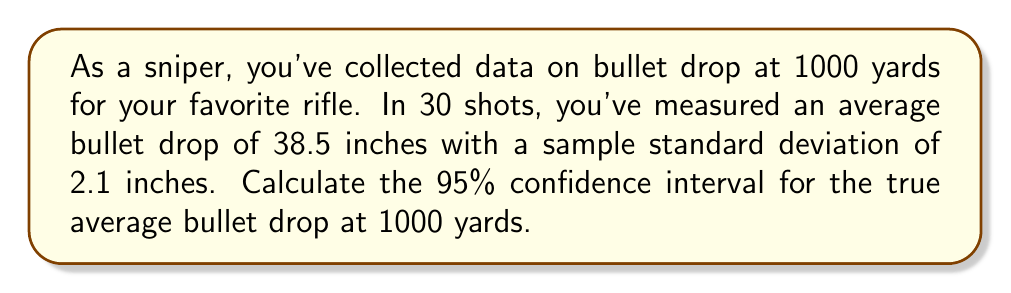Can you answer this question? To calculate the confidence interval, we'll use the t-distribution since we have a small sample size (n < 30) and don't know the population standard deviation. Here are the steps:

1. Identify the given information:
   - Sample size: $n = 30$
   - Sample mean: $\bar{x} = 38.5$ inches
   - Sample standard deviation: $s = 2.1$ inches
   - Confidence level: 95% (α = 0.05)

2. Find the critical t-value:
   - Degrees of freedom: $df = n - 1 = 29$
   - For a 95% confidence interval, we need $t_{0.025, 29}$
   - Using a t-table or calculator, we find $t_{0.025, 29} ≈ 2.045$

3. Calculate the margin of error:
   $\text{ME} = t_{0.025, 29} \cdot \frac{s}{\sqrt{n}}$
   $\text{ME} = 2.045 \cdot \frac{2.1}{\sqrt{30}} ≈ 0.784$

4. Compute the confidence interval:
   $\text{CI} = \bar{x} \pm \text{ME}$
   $\text{CI} = 38.5 \pm 0.784$
   
   Lower bound: $38.5 - 0.784 = 37.716$
   Upper bound: $38.5 + 0.784 = 39.284$

Therefore, we can be 95% confident that the true average bullet drop at 1000 yards is between 37.716 inches and 39.284 inches.
Answer: (37.716, 39.284) inches 